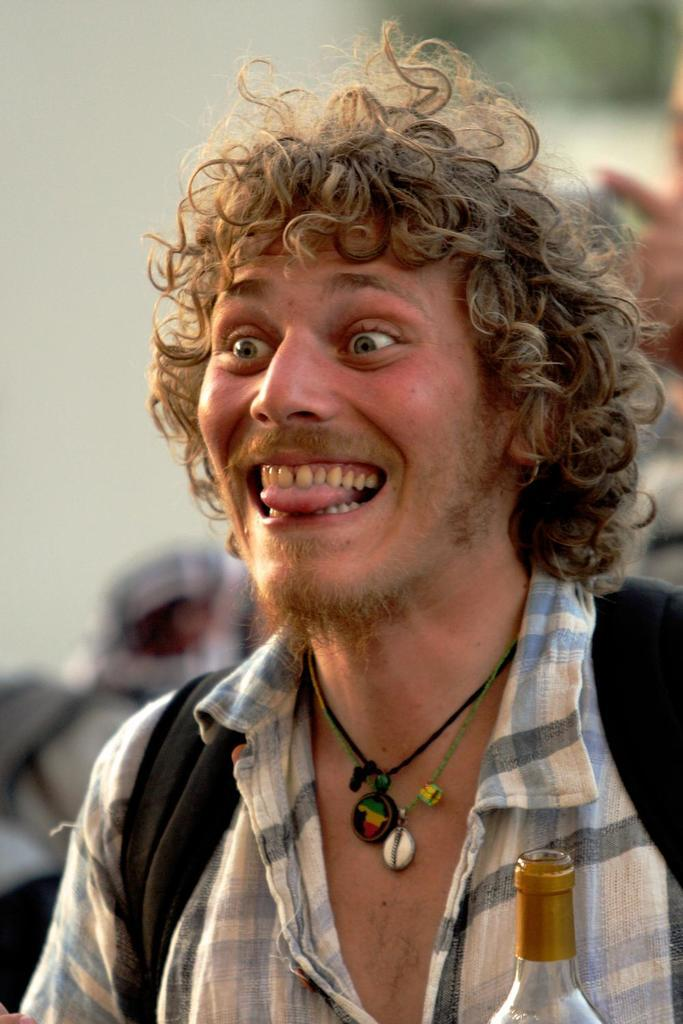What is the main subject of the image? There is a person in the image. What is the person wearing on their body? The person is wearing a bag. What accessory is the person wearing around their neck? The person is wearing a black thread with a locket on their neck. What is the person's facial expression in the image? The person is smiling. What object can be seen in the front of the image? There is a bottle in the front of the image. How would you describe the background of the image? The background of the image is blurred. How does the person in the image blow air through the hole in the bottle? There is no hole in the bottle present in the image, and therefore no such action can be observed. 